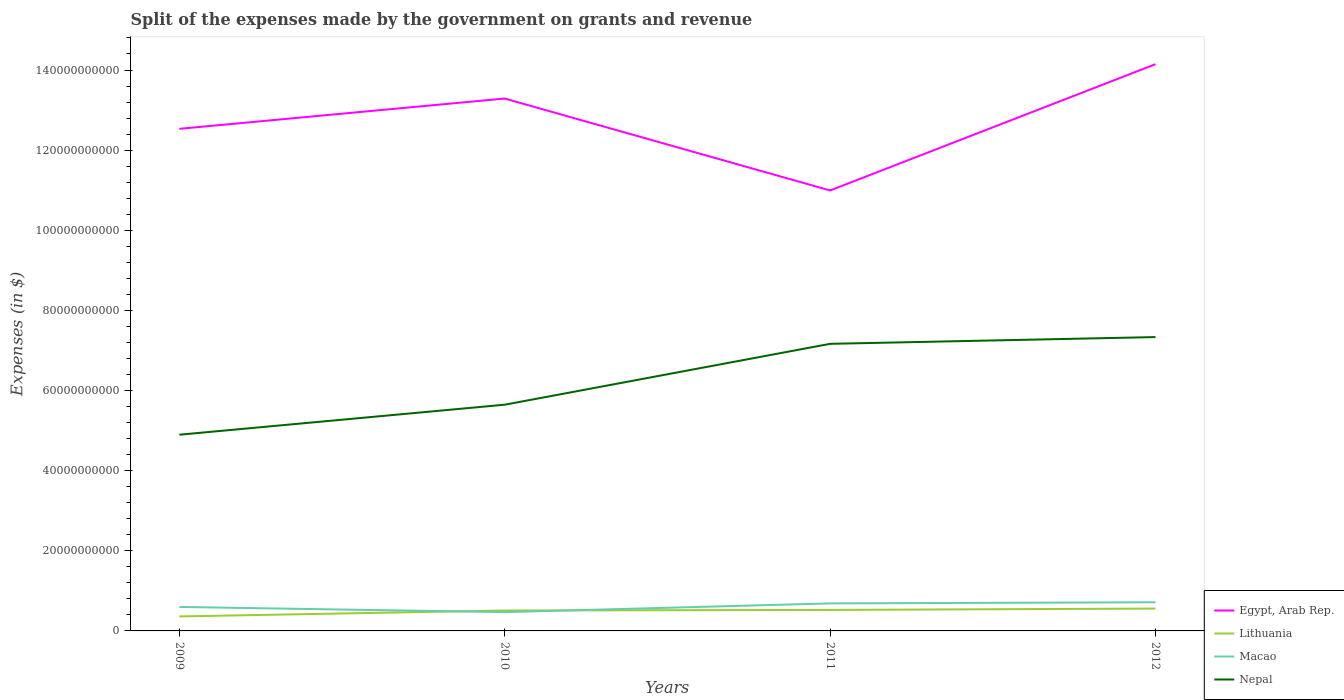How many different coloured lines are there?
Your response must be concise. 4. Does the line corresponding to Egypt, Arab Rep. intersect with the line corresponding to Nepal?
Your response must be concise. No. Across all years, what is the maximum expenses made by the government on grants and revenue in Lithuania?
Your answer should be compact. 3.62e+09. In which year was the expenses made by the government on grants and revenue in Nepal maximum?
Ensure brevity in your answer.  2009. What is the total expenses made by the government on grants and revenue in Lithuania in the graph?
Your response must be concise. -3.35e+08. What is the difference between the highest and the second highest expenses made by the government on grants and revenue in Macao?
Keep it short and to the point. 2.47e+09. Is the expenses made by the government on grants and revenue in Egypt, Arab Rep. strictly greater than the expenses made by the government on grants and revenue in Lithuania over the years?
Offer a very short reply. No. How many years are there in the graph?
Offer a very short reply. 4. Are the values on the major ticks of Y-axis written in scientific E-notation?
Provide a short and direct response. No. Does the graph contain grids?
Your response must be concise. No. How many legend labels are there?
Ensure brevity in your answer.  4. How are the legend labels stacked?
Provide a succinct answer. Vertical. What is the title of the graph?
Your answer should be very brief. Split of the expenses made by the government on grants and revenue. Does "Iran" appear as one of the legend labels in the graph?
Ensure brevity in your answer.  No. What is the label or title of the X-axis?
Give a very brief answer. Years. What is the label or title of the Y-axis?
Offer a very short reply. Expenses (in $). What is the Expenses (in $) in Egypt, Arab Rep. in 2009?
Keep it short and to the point. 1.25e+11. What is the Expenses (in $) of Lithuania in 2009?
Your answer should be compact. 3.62e+09. What is the Expenses (in $) of Macao in 2009?
Offer a terse response. 5.99e+09. What is the Expenses (in $) of Nepal in 2009?
Offer a very short reply. 4.90e+1. What is the Expenses (in $) of Egypt, Arab Rep. in 2010?
Your answer should be compact. 1.33e+11. What is the Expenses (in $) of Lithuania in 2010?
Provide a succinct answer. 5.09e+09. What is the Expenses (in $) of Macao in 2010?
Offer a very short reply. 4.69e+09. What is the Expenses (in $) of Nepal in 2010?
Offer a very short reply. 5.65e+1. What is the Expenses (in $) in Egypt, Arab Rep. in 2011?
Provide a succinct answer. 1.10e+11. What is the Expenses (in $) of Lithuania in 2011?
Ensure brevity in your answer.  5.24e+09. What is the Expenses (in $) of Macao in 2011?
Ensure brevity in your answer.  6.87e+09. What is the Expenses (in $) of Nepal in 2011?
Make the answer very short. 7.17e+1. What is the Expenses (in $) in Egypt, Arab Rep. in 2012?
Your answer should be compact. 1.41e+11. What is the Expenses (in $) in Lithuania in 2012?
Offer a terse response. 5.58e+09. What is the Expenses (in $) in Macao in 2012?
Ensure brevity in your answer.  7.16e+09. What is the Expenses (in $) of Nepal in 2012?
Your response must be concise. 7.33e+1. Across all years, what is the maximum Expenses (in $) in Egypt, Arab Rep.?
Make the answer very short. 1.41e+11. Across all years, what is the maximum Expenses (in $) in Lithuania?
Provide a succinct answer. 5.58e+09. Across all years, what is the maximum Expenses (in $) of Macao?
Make the answer very short. 7.16e+09. Across all years, what is the maximum Expenses (in $) in Nepal?
Give a very brief answer. 7.33e+1. Across all years, what is the minimum Expenses (in $) of Egypt, Arab Rep.?
Your answer should be very brief. 1.10e+11. Across all years, what is the minimum Expenses (in $) of Lithuania?
Keep it short and to the point. 3.62e+09. Across all years, what is the minimum Expenses (in $) in Macao?
Your answer should be compact. 4.69e+09. Across all years, what is the minimum Expenses (in $) of Nepal?
Your response must be concise. 4.90e+1. What is the total Expenses (in $) of Egypt, Arab Rep. in the graph?
Your response must be concise. 5.10e+11. What is the total Expenses (in $) of Lithuania in the graph?
Give a very brief answer. 1.95e+1. What is the total Expenses (in $) in Macao in the graph?
Provide a succinct answer. 2.47e+1. What is the total Expenses (in $) in Nepal in the graph?
Offer a very short reply. 2.50e+11. What is the difference between the Expenses (in $) of Egypt, Arab Rep. in 2009 and that in 2010?
Give a very brief answer. -7.56e+09. What is the difference between the Expenses (in $) in Lithuania in 2009 and that in 2010?
Provide a succinct answer. -1.47e+09. What is the difference between the Expenses (in $) of Macao in 2009 and that in 2010?
Offer a terse response. 1.30e+09. What is the difference between the Expenses (in $) of Nepal in 2009 and that in 2010?
Your response must be concise. -7.49e+09. What is the difference between the Expenses (in $) of Egypt, Arab Rep. in 2009 and that in 2011?
Offer a terse response. 1.54e+1. What is the difference between the Expenses (in $) in Lithuania in 2009 and that in 2011?
Offer a very short reply. -1.62e+09. What is the difference between the Expenses (in $) of Macao in 2009 and that in 2011?
Your answer should be very brief. -8.85e+08. What is the difference between the Expenses (in $) of Nepal in 2009 and that in 2011?
Keep it short and to the point. -2.27e+1. What is the difference between the Expenses (in $) in Egypt, Arab Rep. in 2009 and that in 2012?
Ensure brevity in your answer.  -1.61e+1. What is the difference between the Expenses (in $) of Lithuania in 2009 and that in 2012?
Provide a short and direct response. -1.96e+09. What is the difference between the Expenses (in $) of Macao in 2009 and that in 2012?
Make the answer very short. -1.17e+09. What is the difference between the Expenses (in $) in Nepal in 2009 and that in 2012?
Your response must be concise. -2.44e+1. What is the difference between the Expenses (in $) of Egypt, Arab Rep. in 2010 and that in 2011?
Keep it short and to the point. 2.29e+1. What is the difference between the Expenses (in $) in Lithuania in 2010 and that in 2011?
Offer a terse response. -1.51e+08. What is the difference between the Expenses (in $) of Macao in 2010 and that in 2011?
Make the answer very short. -2.18e+09. What is the difference between the Expenses (in $) in Nepal in 2010 and that in 2011?
Offer a very short reply. -1.52e+1. What is the difference between the Expenses (in $) of Egypt, Arab Rep. in 2010 and that in 2012?
Provide a succinct answer. -8.57e+09. What is the difference between the Expenses (in $) in Lithuania in 2010 and that in 2012?
Give a very brief answer. -4.86e+08. What is the difference between the Expenses (in $) of Macao in 2010 and that in 2012?
Keep it short and to the point. -2.47e+09. What is the difference between the Expenses (in $) in Nepal in 2010 and that in 2012?
Give a very brief answer. -1.69e+1. What is the difference between the Expenses (in $) of Egypt, Arab Rep. in 2011 and that in 2012?
Ensure brevity in your answer.  -3.15e+1. What is the difference between the Expenses (in $) in Lithuania in 2011 and that in 2012?
Your answer should be very brief. -3.35e+08. What is the difference between the Expenses (in $) in Macao in 2011 and that in 2012?
Offer a very short reply. -2.84e+08. What is the difference between the Expenses (in $) of Nepal in 2011 and that in 2012?
Your response must be concise. -1.69e+09. What is the difference between the Expenses (in $) of Egypt, Arab Rep. in 2009 and the Expenses (in $) of Lithuania in 2010?
Provide a short and direct response. 1.20e+11. What is the difference between the Expenses (in $) of Egypt, Arab Rep. in 2009 and the Expenses (in $) of Macao in 2010?
Your answer should be compact. 1.21e+11. What is the difference between the Expenses (in $) of Egypt, Arab Rep. in 2009 and the Expenses (in $) of Nepal in 2010?
Your answer should be very brief. 6.89e+1. What is the difference between the Expenses (in $) of Lithuania in 2009 and the Expenses (in $) of Macao in 2010?
Offer a very short reply. -1.07e+09. What is the difference between the Expenses (in $) of Lithuania in 2009 and the Expenses (in $) of Nepal in 2010?
Provide a succinct answer. -5.28e+1. What is the difference between the Expenses (in $) in Macao in 2009 and the Expenses (in $) in Nepal in 2010?
Make the answer very short. -5.05e+1. What is the difference between the Expenses (in $) of Egypt, Arab Rep. in 2009 and the Expenses (in $) of Lithuania in 2011?
Ensure brevity in your answer.  1.20e+11. What is the difference between the Expenses (in $) of Egypt, Arab Rep. in 2009 and the Expenses (in $) of Macao in 2011?
Provide a succinct answer. 1.18e+11. What is the difference between the Expenses (in $) of Egypt, Arab Rep. in 2009 and the Expenses (in $) of Nepal in 2011?
Your answer should be very brief. 5.37e+1. What is the difference between the Expenses (in $) in Lithuania in 2009 and the Expenses (in $) in Macao in 2011?
Make the answer very short. -3.25e+09. What is the difference between the Expenses (in $) in Lithuania in 2009 and the Expenses (in $) in Nepal in 2011?
Ensure brevity in your answer.  -6.80e+1. What is the difference between the Expenses (in $) in Macao in 2009 and the Expenses (in $) in Nepal in 2011?
Provide a short and direct response. -6.57e+1. What is the difference between the Expenses (in $) of Egypt, Arab Rep. in 2009 and the Expenses (in $) of Lithuania in 2012?
Your answer should be compact. 1.20e+11. What is the difference between the Expenses (in $) of Egypt, Arab Rep. in 2009 and the Expenses (in $) of Macao in 2012?
Offer a terse response. 1.18e+11. What is the difference between the Expenses (in $) in Egypt, Arab Rep. in 2009 and the Expenses (in $) in Nepal in 2012?
Your response must be concise. 5.20e+1. What is the difference between the Expenses (in $) in Lithuania in 2009 and the Expenses (in $) in Macao in 2012?
Keep it short and to the point. -3.54e+09. What is the difference between the Expenses (in $) in Lithuania in 2009 and the Expenses (in $) in Nepal in 2012?
Give a very brief answer. -6.97e+1. What is the difference between the Expenses (in $) in Macao in 2009 and the Expenses (in $) in Nepal in 2012?
Keep it short and to the point. -6.74e+1. What is the difference between the Expenses (in $) in Egypt, Arab Rep. in 2010 and the Expenses (in $) in Lithuania in 2011?
Make the answer very short. 1.28e+11. What is the difference between the Expenses (in $) of Egypt, Arab Rep. in 2010 and the Expenses (in $) of Macao in 2011?
Keep it short and to the point. 1.26e+11. What is the difference between the Expenses (in $) of Egypt, Arab Rep. in 2010 and the Expenses (in $) of Nepal in 2011?
Provide a short and direct response. 6.12e+1. What is the difference between the Expenses (in $) of Lithuania in 2010 and the Expenses (in $) of Macao in 2011?
Keep it short and to the point. -1.78e+09. What is the difference between the Expenses (in $) of Lithuania in 2010 and the Expenses (in $) of Nepal in 2011?
Offer a very short reply. -6.66e+1. What is the difference between the Expenses (in $) of Macao in 2010 and the Expenses (in $) of Nepal in 2011?
Your response must be concise. -6.70e+1. What is the difference between the Expenses (in $) of Egypt, Arab Rep. in 2010 and the Expenses (in $) of Lithuania in 2012?
Your answer should be compact. 1.27e+11. What is the difference between the Expenses (in $) in Egypt, Arab Rep. in 2010 and the Expenses (in $) in Macao in 2012?
Your answer should be very brief. 1.26e+11. What is the difference between the Expenses (in $) of Egypt, Arab Rep. in 2010 and the Expenses (in $) of Nepal in 2012?
Ensure brevity in your answer.  5.95e+1. What is the difference between the Expenses (in $) in Lithuania in 2010 and the Expenses (in $) in Macao in 2012?
Keep it short and to the point. -2.06e+09. What is the difference between the Expenses (in $) of Lithuania in 2010 and the Expenses (in $) of Nepal in 2012?
Your answer should be very brief. -6.83e+1. What is the difference between the Expenses (in $) of Macao in 2010 and the Expenses (in $) of Nepal in 2012?
Provide a succinct answer. -6.87e+1. What is the difference between the Expenses (in $) of Egypt, Arab Rep. in 2011 and the Expenses (in $) of Lithuania in 2012?
Ensure brevity in your answer.  1.04e+11. What is the difference between the Expenses (in $) of Egypt, Arab Rep. in 2011 and the Expenses (in $) of Macao in 2012?
Provide a short and direct response. 1.03e+11. What is the difference between the Expenses (in $) of Egypt, Arab Rep. in 2011 and the Expenses (in $) of Nepal in 2012?
Keep it short and to the point. 3.66e+1. What is the difference between the Expenses (in $) in Lithuania in 2011 and the Expenses (in $) in Macao in 2012?
Your answer should be very brief. -1.91e+09. What is the difference between the Expenses (in $) of Lithuania in 2011 and the Expenses (in $) of Nepal in 2012?
Offer a terse response. -6.81e+1. What is the difference between the Expenses (in $) of Macao in 2011 and the Expenses (in $) of Nepal in 2012?
Offer a terse response. -6.65e+1. What is the average Expenses (in $) of Egypt, Arab Rep. per year?
Make the answer very short. 1.27e+11. What is the average Expenses (in $) in Lithuania per year?
Provide a succinct answer. 4.88e+09. What is the average Expenses (in $) in Macao per year?
Make the answer very short. 6.18e+09. What is the average Expenses (in $) of Nepal per year?
Your answer should be compact. 6.26e+1. In the year 2009, what is the difference between the Expenses (in $) of Egypt, Arab Rep. and Expenses (in $) of Lithuania?
Offer a very short reply. 1.22e+11. In the year 2009, what is the difference between the Expenses (in $) in Egypt, Arab Rep. and Expenses (in $) in Macao?
Make the answer very short. 1.19e+11. In the year 2009, what is the difference between the Expenses (in $) in Egypt, Arab Rep. and Expenses (in $) in Nepal?
Make the answer very short. 7.63e+1. In the year 2009, what is the difference between the Expenses (in $) of Lithuania and Expenses (in $) of Macao?
Offer a terse response. -2.37e+09. In the year 2009, what is the difference between the Expenses (in $) in Lithuania and Expenses (in $) in Nepal?
Offer a very short reply. -4.54e+1. In the year 2009, what is the difference between the Expenses (in $) in Macao and Expenses (in $) in Nepal?
Your response must be concise. -4.30e+1. In the year 2010, what is the difference between the Expenses (in $) of Egypt, Arab Rep. and Expenses (in $) of Lithuania?
Make the answer very short. 1.28e+11. In the year 2010, what is the difference between the Expenses (in $) in Egypt, Arab Rep. and Expenses (in $) in Macao?
Your response must be concise. 1.28e+11. In the year 2010, what is the difference between the Expenses (in $) in Egypt, Arab Rep. and Expenses (in $) in Nepal?
Keep it short and to the point. 7.64e+1. In the year 2010, what is the difference between the Expenses (in $) in Lithuania and Expenses (in $) in Macao?
Keep it short and to the point. 4.02e+08. In the year 2010, what is the difference between the Expenses (in $) in Lithuania and Expenses (in $) in Nepal?
Your answer should be compact. -5.14e+1. In the year 2010, what is the difference between the Expenses (in $) of Macao and Expenses (in $) of Nepal?
Keep it short and to the point. -5.18e+1. In the year 2011, what is the difference between the Expenses (in $) in Egypt, Arab Rep. and Expenses (in $) in Lithuania?
Offer a terse response. 1.05e+11. In the year 2011, what is the difference between the Expenses (in $) of Egypt, Arab Rep. and Expenses (in $) of Macao?
Offer a terse response. 1.03e+11. In the year 2011, what is the difference between the Expenses (in $) of Egypt, Arab Rep. and Expenses (in $) of Nepal?
Your answer should be very brief. 3.83e+1. In the year 2011, what is the difference between the Expenses (in $) of Lithuania and Expenses (in $) of Macao?
Offer a very short reply. -1.63e+09. In the year 2011, what is the difference between the Expenses (in $) of Lithuania and Expenses (in $) of Nepal?
Provide a short and direct response. -6.64e+1. In the year 2011, what is the difference between the Expenses (in $) of Macao and Expenses (in $) of Nepal?
Provide a succinct answer. -6.48e+1. In the year 2012, what is the difference between the Expenses (in $) in Egypt, Arab Rep. and Expenses (in $) in Lithuania?
Keep it short and to the point. 1.36e+11. In the year 2012, what is the difference between the Expenses (in $) in Egypt, Arab Rep. and Expenses (in $) in Macao?
Provide a succinct answer. 1.34e+11. In the year 2012, what is the difference between the Expenses (in $) of Egypt, Arab Rep. and Expenses (in $) of Nepal?
Your answer should be compact. 6.81e+1. In the year 2012, what is the difference between the Expenses (in $) of Lithuania and Expenses (in $) of Macao?
Give a very brief answer. -1.58e+09. In the year 2012, what is the difference between the Expenses (in $) of Lithuania and Expenses (in $) of Nepal?
Your answer should be compact. -6.78e+1. In the year 2012, what is the difference between the Expenses (in $) of Macao and Expenses (in $) of Nepal?
Your answer should be compact. -6.62e+1. What is the ratio of the Expenses (in $) of Egypt, Arab Rep. in 2009 to that in 2010?
Your answer should be compact. 0.94. What is the ratio of the Expenses (in $) in Lithuania in 2009 to that in 2010?
Ensure brevity in your answer.  0.71. What is the ratio of the Expenses (in $) in Macao in 2009 to that in 2010?
Give a very brief answer. 1.28. What is the ratio of the Expenses (in $) of Nepal in 2009 to that in 2010?
Make the answer very short. 0.87. What is the ratio of the Expenses (in $) of Egypt, Arab Rep. in 2009 to that in 2011?
Ensure brevity in your answer.  1.14. What is the ratio of the Expenses (in $) in Lithuania in 2009 to that in 2011?
Give a very brief answer. 0.69. What is the ratio of the Expenses (in $) of Macao in 2009 to that in 2011?
Provide a short and direct response. 0.87. What is the ratio of the Expenses (in $) in Nepal in 2009 to that in 2011?
Your answer should be compact. 0.68. What is the ratio of the Expenses (in $) of Egypt, Arab Rep. in 2009 to that in 2012?
Your answer should be compact. 0.89. What is the ratio of the Expenses (in $) in Lithuania in 2009 to that in 2012?
Ensure brevity in your answer.  0.65. What is the ratio of the Expenses (in $) in Macao in 2009 to that in 2012?
Provide a succinct answer. 0.84. What is the ratio of the Expenses (in $) in Nepal in 2009 to that in 2012?
Provide a short and direct response. 0.67. What is the ratio of the Expenses (in $) of Egypt, Arab Rep. in 2010 to that in 2011?
Ensure brevity in your answer.  1.21. What is the ratio of the Expenses (in $) in Lithuania in 2010 to that in 2011?
Keep it short and to the point. 0.97. What is the ratio of the Expenses (in $) of Macao in 2010 to that in 2011?
Offer a terse response. 0.68. What is the ratio of the Expenses (in $) of Nepal in 2010 to that in 2011?
Provide a short and direct response. 0.79. What is the ratio of the Expenses (in $) in Egypt, Arab Rep. in 2010 to that in 2012?
Your answer should be very brief. 0.94. What is the ratio of the Expenses (in $) of Lithuania in 2010 to that in 2012?
Provide a succinct answer. 0.91. What is the ratio of the Expenses (in $) in Macao in 2010 to that in 2012?
Give a very brief answer. 0.66. What is the ratio of the Expenses (in $) of Nepal in 2010 to that in 2012?
Offer a terse response. 0.77. What is the ratio of the Expenses (in $) of Egypt, Arab Rep. in 2011 to that in 2012?
Offer a very short reply. 0.78. What is the ratio of the Expenses (in $) in Lithuania in 2011 to that in 2012?
Ensure brevity in your answer.  0.94. What is the ratio of the Expenses (in $) in Macao in 2011 to that in 2012?
Offer a very short reply. 0.96. What is the ratio of the Expenses (in $) in Nepal in 2011 to that in 2012?
Offer a very short reply. 0.98. What is the difference between the highest and the second highest Expenses (in $) in Egypt, Arab Rep.?
Make the answer very short. 8.57e+09. What is the difference between the highest and the second highest Expenses (in $) in Lithuania?
Offer a very short reply. 3.35e+08. What is the difference between the highest and the second highest Expenses (in $) in Macao?
Ensure brevity in your answer.  2.84e+08. What is the difference between the highest and the second highest Expenses (in $) of Nepal?
Provide a succinct answer. 1.69e+09. What is the difference between the highest and the lowest Expenses (in $) of Egypt, Arab Rep.?
Offer a very short reply. 3.15e+1. What is the difference between the highest and the lowest Expenses (in $) of Lithuania?
Your answer should be compact. 1.96e+09. What is the difference between the highest and the lowest Expenses (in $) of Macao?
Provide a succinct answer. 2.47e+09. What is the difference between the highest and the lowest Expenses (in $) of Nepal?
Ensure brevity in your answer.  2.44e+1. 